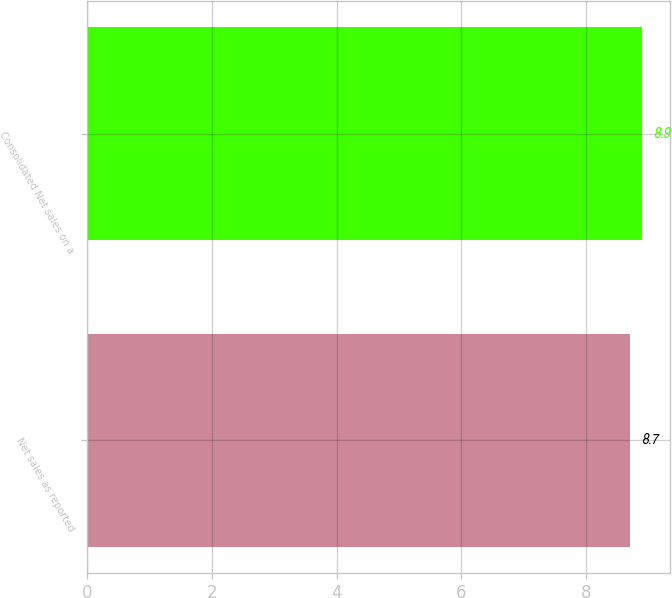Convert chart to OTSL. <chart><loc_0><loc_0><loc_500><loc_500><bar_chart><fcel>Net sales as reported<fcel>Consolidated Net sales on a<nl><fcel>8.7<fcel>8.9<nl></chart> 